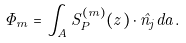Convert formula to latex. <formula><loc_0><loc_0><loc_500><loc_500>\Phi _ { m } = \int _ { A } { S } ^ { ( m ) } _ { P } ( z ) \cdot \hat { n } _ { j } d a .</formula> 